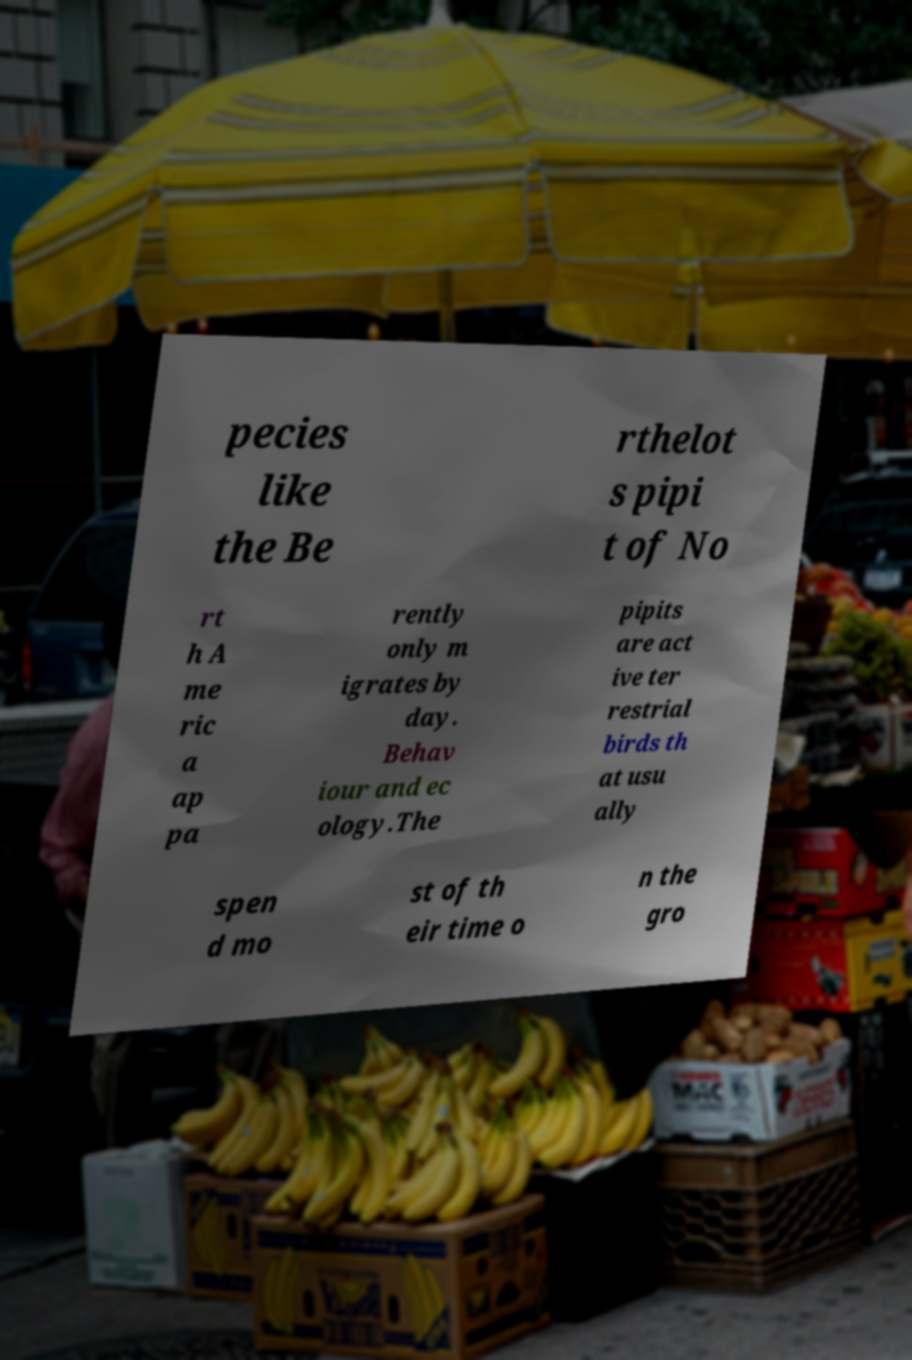I need the written content from this picture converted into text. Can you do that? pecies like the Be rthelot s pipi t of No rt h A me ric a ap pa rently only m igrates by day. Behav iour and ec ology.The pipits are act ive ter restrial birds th at usu ally spen d mo st of th eir time o n the gro 